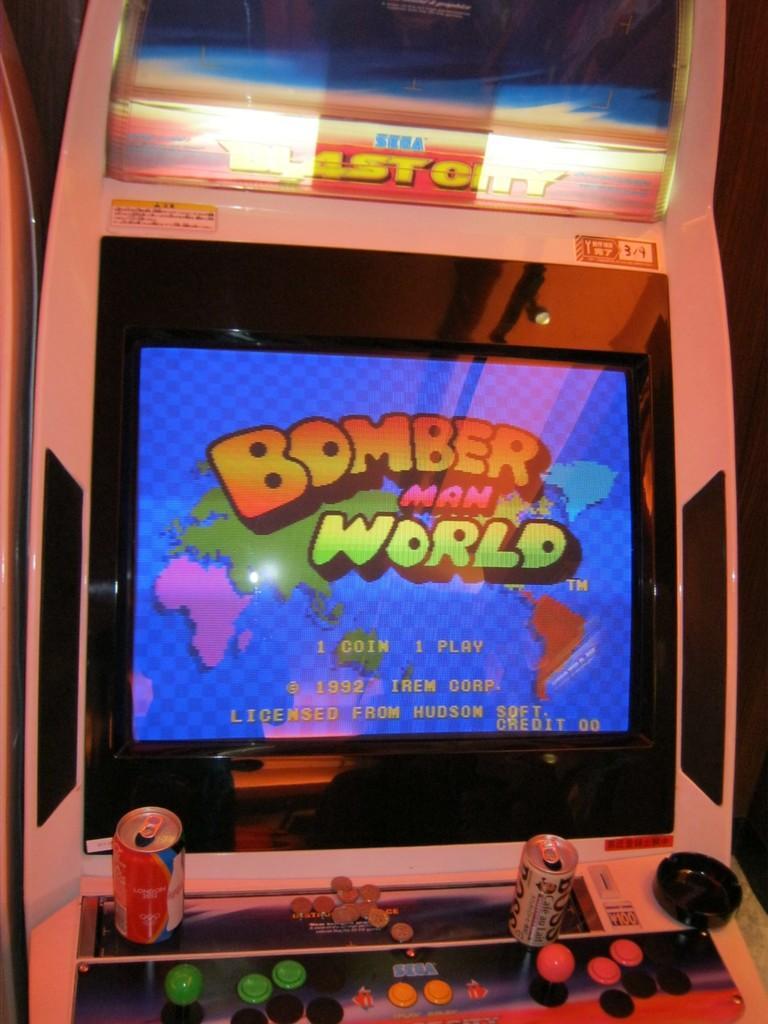How would you summarize this image in a sentence or two? In this image I can see the screen and I can see something written on it. In front I can see two tins and I can also see few balls in multi color. 